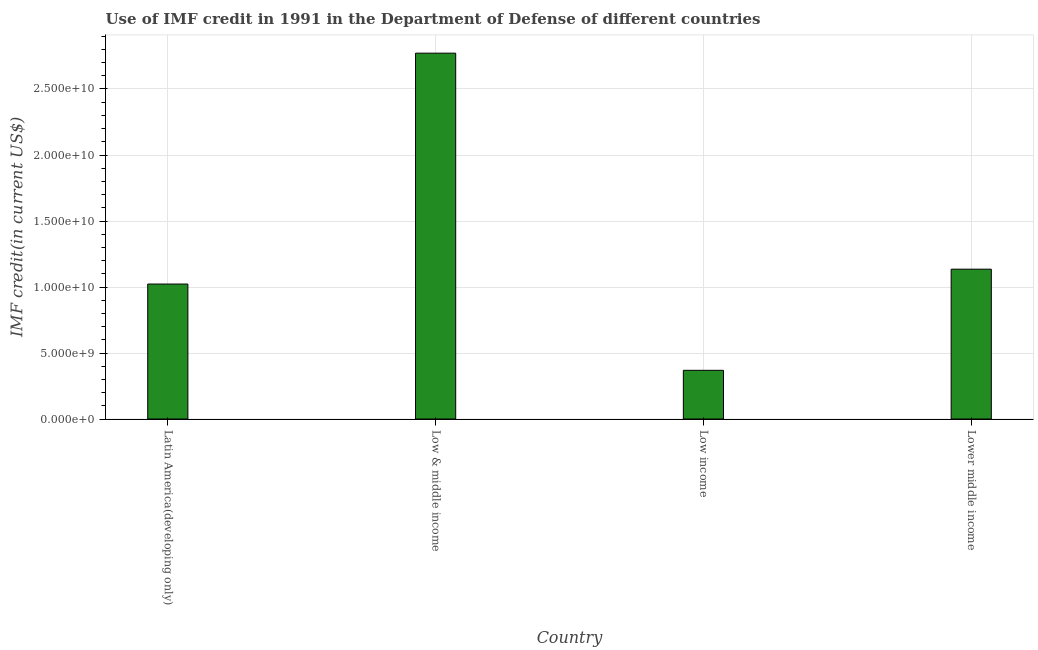What is the title of the graph?
Your answer should be very brief. Use of IMF credit in 1991 in the Department of Defense of different countries. What is the label or title of the X-axis?
Your answer should be very brief. Country. What is the label or title of the Y-axis?
Provide a succinct answer. IMF credit(in current US$). What is the use of imf credit in dod in Latin America(developing only)?
Ensure brevity in your answer.  1.02e+1. Across all countries, what is the maximum use of imf credit in dod?
Give a very brief answer. 2.77e+1. Across all countries, what is the minimum use of imf credit in dod?
Offer a very short reply. 3.69e+09. What is the sum of the use of imf credit in dod?
Your answer should be very brief. 5.30e+1. What is the difference between the use of imf credit in dod in Low & middle income and Lower middle income?
Offer a terse response. 1.64e+1. What is the average use of imf credit in dod per country?
Your response must be concise. 1.32e+1. What is the median use of imf credit in dod?
Give a very brief answer. 1.08e+1. What is the ratio of the use of imf credit in dod in Low & middle income to that in Lower middle income?
Give a very brief answer. 2.44. Is the difference between the use of imf credit in dod in Low & middle income and Lower middle income greater than the difference between any two countries?
Keep it short and to the point. No. What is the difference between the highest and the second highest use of imf credit in dod?
Your response must be concise. 1.64e+1. What is the difference between the highest and the lowest use of imf credit in dod?
Your answer should be compact. 2.40e+1. In how many countries, is the use of imf credit in dod greater than the average use of imf credit in dod taken over all countries?
Ensure brevity in your answer.  1. Are all the bars in the graph horizontal?
Offer a very short reply. No. How many countries are there in the graph?
Keep it short and to the point. 4. What is the difference between two consecutive major ticks on the Y-axis?
Give a very brief answer. 5.00e+09. What is the IMF credit(in current US$) of Latin America(developing only)?
Your response must be concise. 1.02e+1. What is the IMF credit(in current US$) in Low & middle income?
Ensure brevity in your answer.  2.77e+1. What is the IMF credit(in current US$) of Low income?
Provide a succinct answer. 3.69e+09. What is the IMF credit(in current US$) of Lower middle income?
Give a very brief answer. 1.14e+1. What is the difference between the IMF credit(in current US$) in Latin America(developing only) and Low & middle income?
Ensure brevity in your answer.  -1.75e+1. What is the difference between the IMF credit(in current US$) in Latin America(developing only) and Low income?
Ensure brevity in your answer.  6.54e+09. What is the difference between the IMF credit(in current US$) in Latin America(developing only) and Lower middle income?
Provide a succinct answer. -1.13e+09. What is the difference between the IMF credit(in current US$) in Low & middle income and Low income?
Your answer should be very brief. 2.40e+1. What is the difference between the IMF credit(in current US$) in Low & middle income and Lower middle income?
Make the answer very short. 1.64e+1. What is the difference between the IMF credit(in current US$) in Low income and Lower middle income?
Provide a succinct answer. -7.66e+09. What is the ratio of the IMF credit(in current US$) in Latin America(developing only) to that in Low & middle income?
Offer a very short reply. 0.37. What is the ratio of the IMF credit(in current US$) in Latin America(developing only) to that in Low income?
Provide a short and direct response. 2.77. What is the ratio of the IMF credit(in current US$) in Latin America(developing only) to that in Lower middle income?
Provide a succinct answer. 0.9. What is the ratio of the IMF credit(in current US$) in Low & middle income to that in Low income?
Your response must be concise. 7.51. What is the ratio of the IMF credit(in current US$) in Low & middle income to that in Lower middle income?
Offer a very short reply. 2.44. What is the ratio of the IMF credit(in current US$) in Low income to that in Lower middle income?
Your response must be concise. 0.33. 